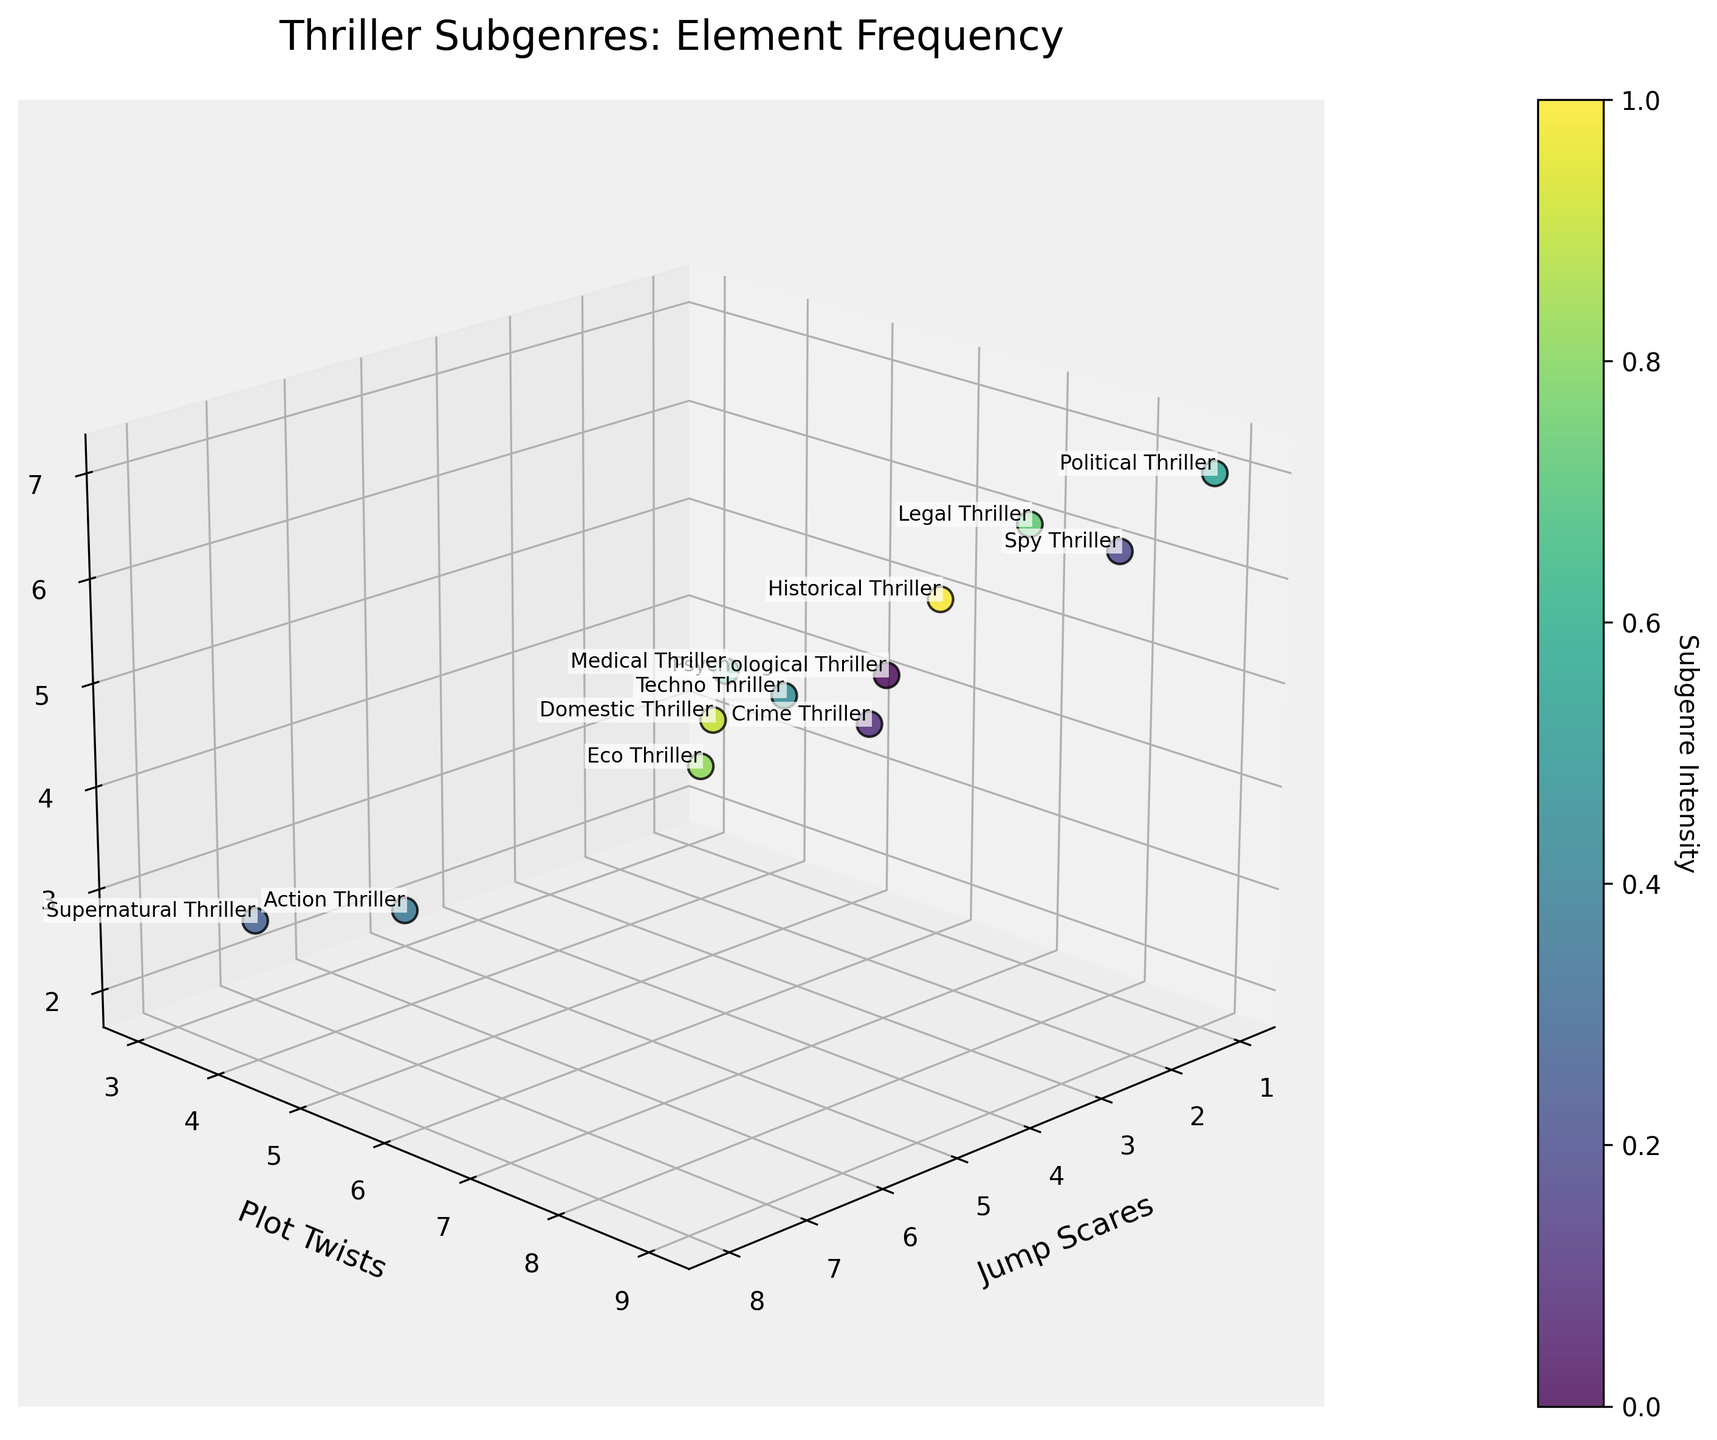What's the title of the plot? The title usually appears at the top of a plot. In this case, it reads "Thriller Subgenres: Element Frequency."
Answer: Thriller Subgenres: Element Frequency What are the axis labels in the plot? The labels for the three axes are essential for understanding what each dimension represents. Here, the x-axis is labeled "Jump Scares," the y-axis is labeled "Plot Twists," and the z-axis is labeled "Dramatic Reveals."
Answer: Jump Scares, Plot Twists, Dramatic Reveals Which subgenre has the highest number of plot twists? By examining the y-axis, which represents plot twists, you can identify which subgenre has the highest value. The subgenre with a value of 9 is the Political Thriller.
Answer: Political Thriller How many subgenres have more than 4 dramatic reveals? Check the z-axis values to count how many subgenres have values greater than 4. These subgenres are Political Thriller, Medical Thriller, Legal Thriller, Psychological Thriller, and Historical Thriller.
Answer: 5 What is the relationship between the number of jump scares and dramatic reveals in Supernatural Thrillers? Look at the position of the Supernatural Thriller regarding the x-axis (jump scares) and z-axis (dramatic reveals). It has 8 jump scares and 3 dramatic reveals.
Answer: 8 jump scares, 3 dramatic reveals Which subgenres have an equal number of plot twists and dramatic reveals? Compare the values on the y-axis (plot twists) and z-axis (dramatic reveals) for each subgenre. The subgenres that match are Spy Thriller and Domestic Thriller.
Answer: Spy Thriller, Domestic Thriller Which subgenre has the lowest number of jump scares, and how many does it have? Look at the x-axis and identify the subgenre with the lowest value, which is 1. There are several subgenres with this value: Political Thriller, Spy Thriller, Historical Thriller, and Legal Thriller.
Answer: Political Thriller, Spy Thriller, Historical Thriller, Legal Thriller What's the average number of plot twists across all subgenres? Sum all the plot twist values (7 + 6 + 8 + 4 + 3 + 5 + 9 + 6 + 7 + 4 + 5+ 6 = 70) and divide by the number of subgenres (12). The calculation is 70 / 12.
Answer: 5.83 Which subgenre has the highest intensity according to the colorbar? The colorbar indicates intensity, which typically ranges from light to dark in the color gradient. The subgenre at the dark end of the gradient has the highest intensity, which is the Political Thriller.
Answer: Political Thriller Do subgenres with more dramatic reveals typically have fewer jump scares? By visually inspecting the scatter plot, we see that subgenres like Political Thriller and Spy Thriller, which have more dramatic reveals, tend to have fewer jump scares (values around 1). Conversely, those with more jump scares have fewer dramatic reveals, such as Supernatural Thriller.
Answer: Yes 